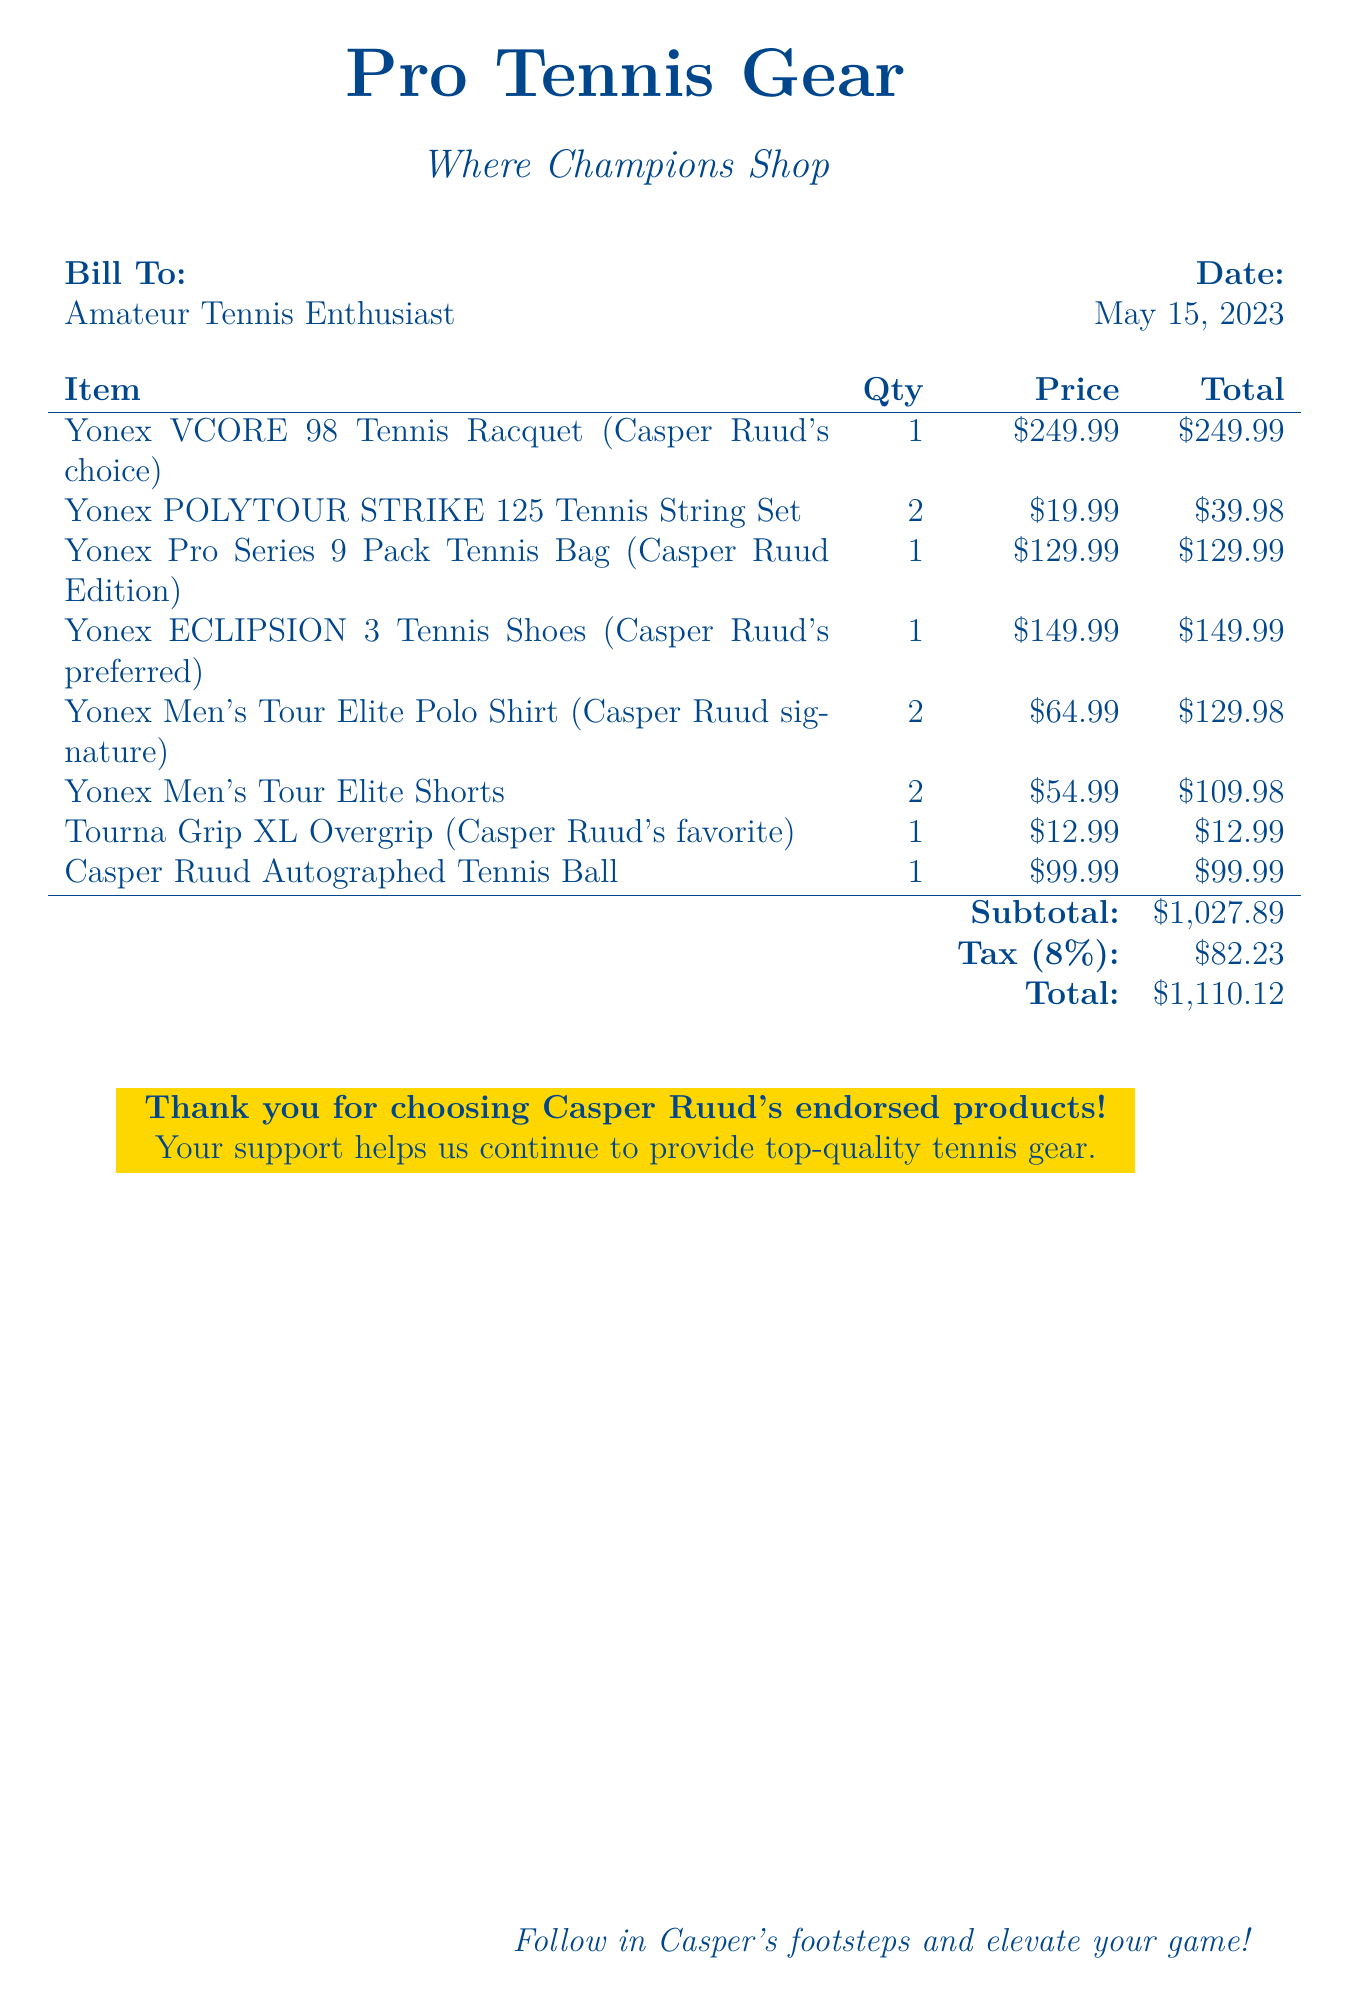What is the date of the bill? The date of the bill is listed on the document, which is May 15, 2023.
Answer: May 15, 2023 Who is the bill addressed to? The document specifies that the bill is addressed to an "Amateur Tennis Enthusiast."
Answer: Amateur Tennis Enthusiast How many Yonex Men's Tour Elite Polo Shirts were purchased? The document states that 2 Yonex Men's Tour Elite Polo Shirts were included in the bill.
Answer: 2 What is the total amount due including tax? The total amount due, including tax, is calculated on the document and is provided as the final total.
Answer: $1,110.12 What is the price of the Yonex VCORE 98 Tennis Racquet? The document lists the price of the Yonex VCORE 98 Tennis Racquet specifically as $249.99.
Answer: $249.99 How much was paid for the Casper Ruud Autographed Tennis Ball? The document specifies the cost of the Casper Ruud Autographed Tennis Ball as $99.99.
Answer: $99.99 What is the subtotal before tax? The subtotal before tax is detailed in the bill as the sum of all items listed without tax.
Answer: $1,027.89 What percentage is the tax on the total amount? The tax percentage is explicitly stated in the document as 8%.
Answer: 8% What is unique about the Yonex Pro Series 9 Pack Tennis Bag? The document highlights that it is a "Casper Ruud Edition," indicating a special or endorsed version.
Answer: Casper Ruud Edition 